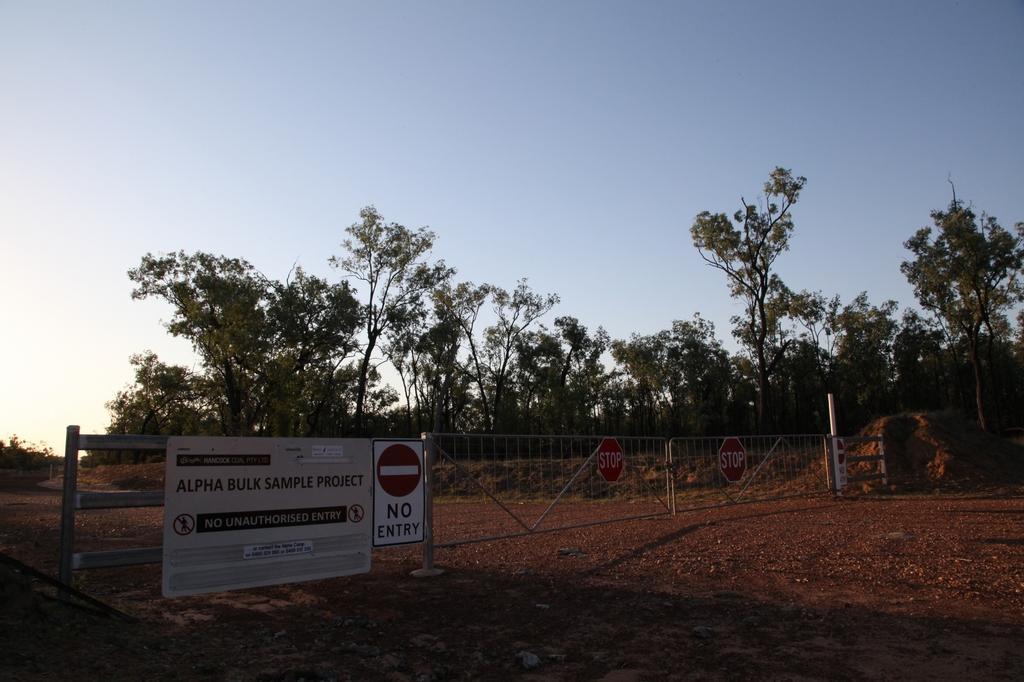How would you summarize this image in a sentence or two? In this image I can see few trees and the board and few sign boards are attached to the fencing. I can see the sky. 